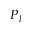<formula> <loc_0><loc_0><loc_500><loc_500>P _ { l }</formula> 